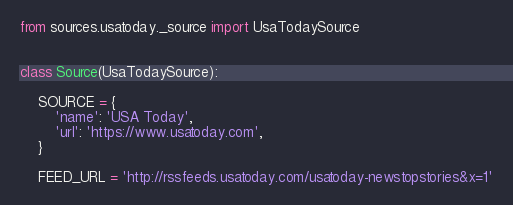Convert code to text. <code><loc_0><loc_0><loc_500><loc_500><_Python_>from sources.usatoday._source import UsaTodaySource


class Source(UsaTodaySource):

    SOURCE = {
        'name': 'USA Today',
        'url': 'https://www.usatoday.com',
    }

    FEED_URL = 'http://rssfeeds.usatoday.com/usatoday-newstopstories&x=1'
</code> 